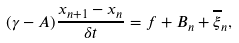<formula> <loc_0><loc_0><loc_500><loc_500>( \gamma - A ) \frac { x _ { n + 1 } - x _ { n } } { \delta t } = f + B _ { n } + \overline { \xi } _ { n } ,</formula> 